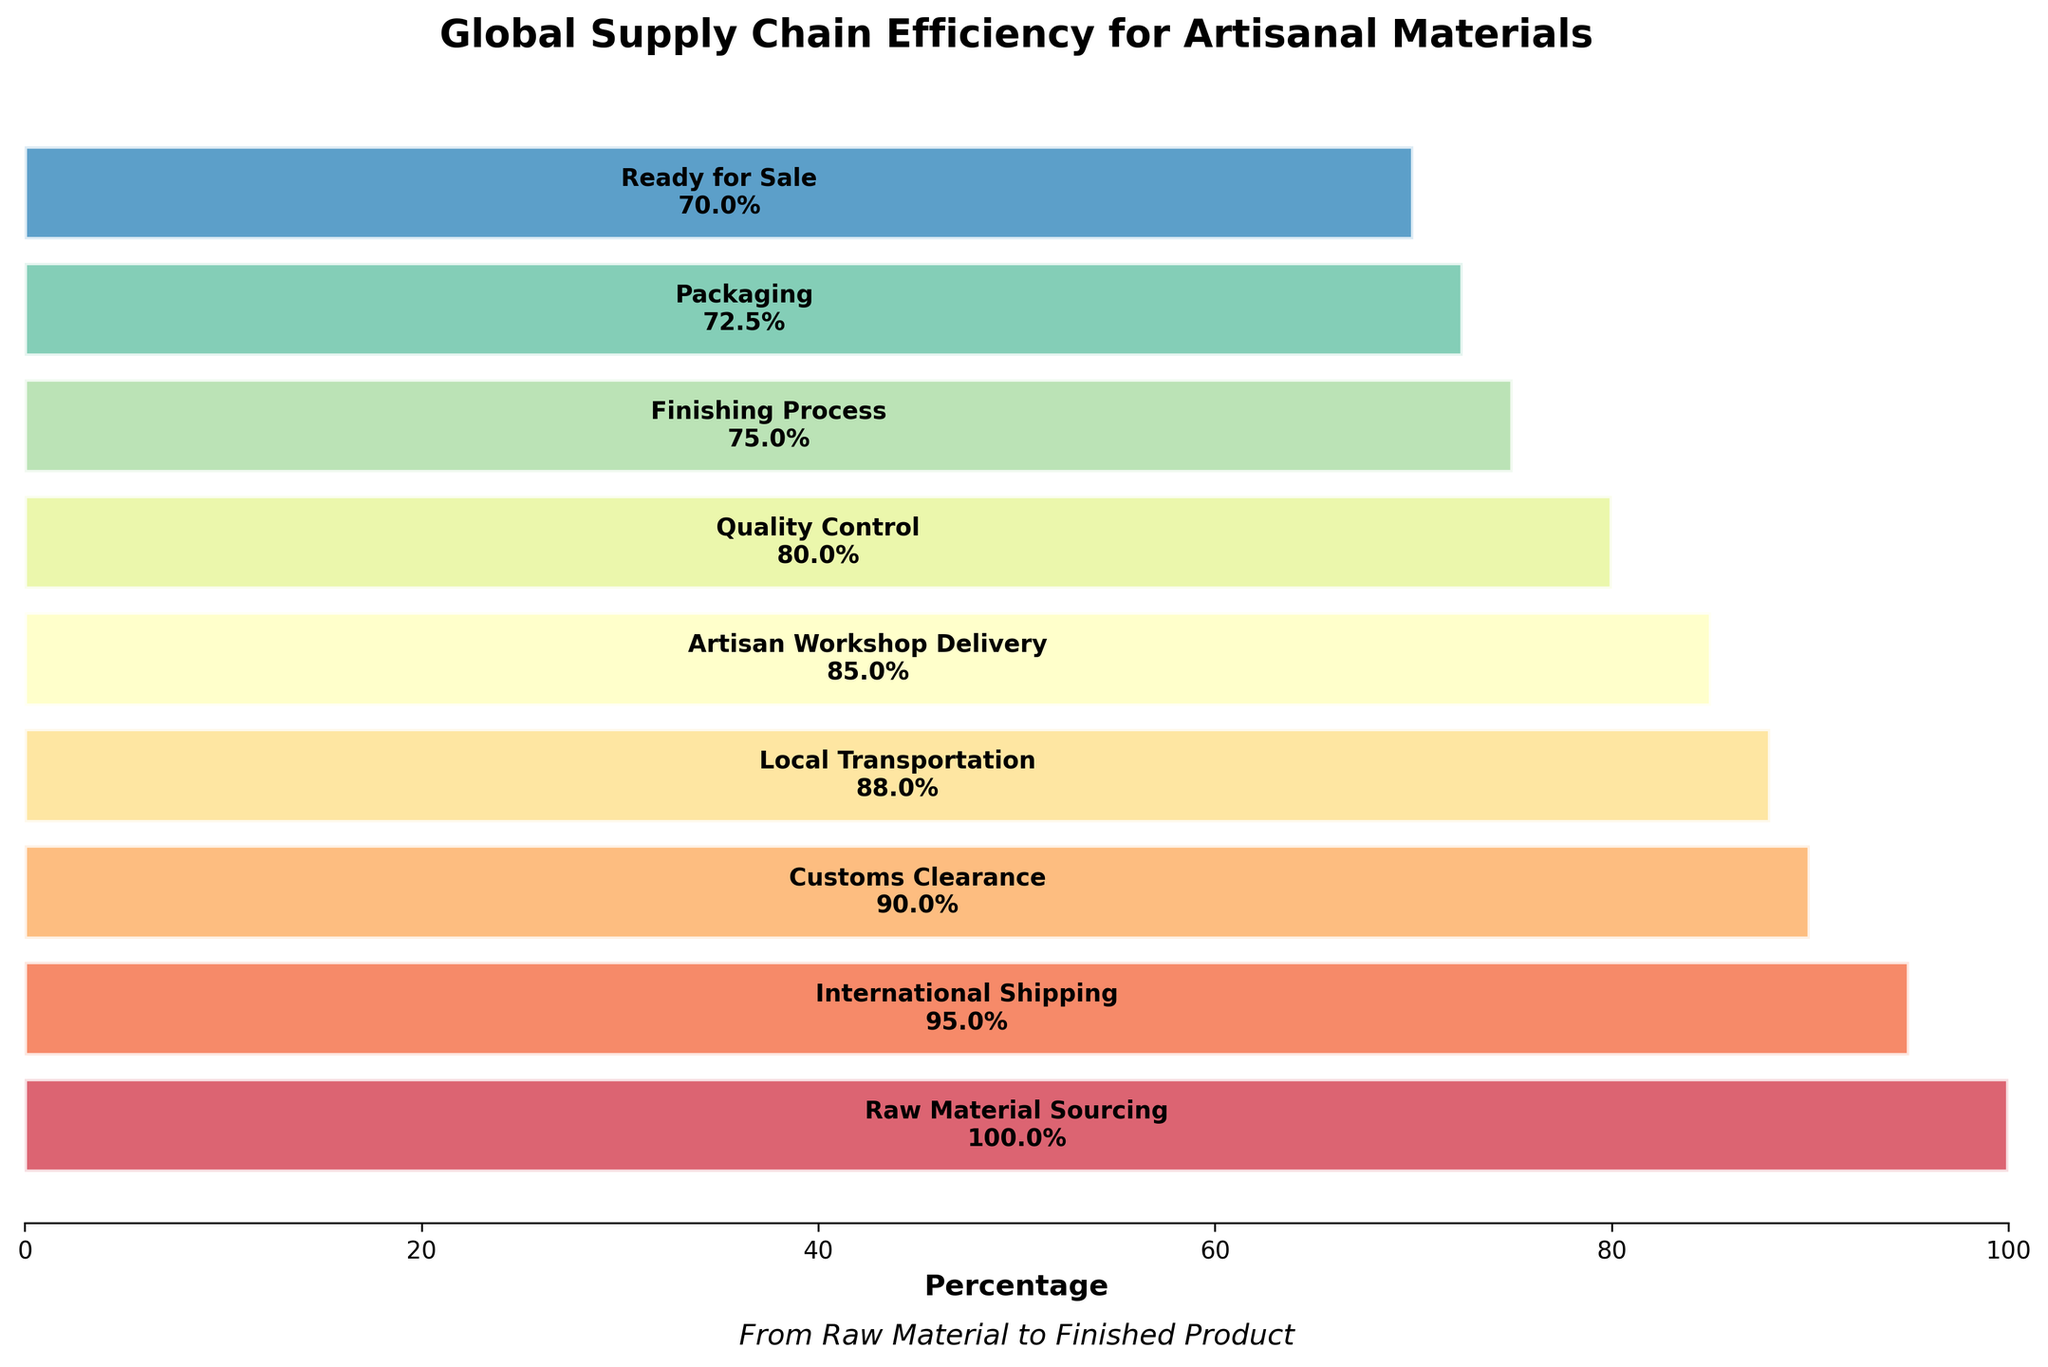What's the title of the figure? The title is displayed at the top of the figure.
Answer: Global Supply Chain Efficiency for Artisanal Materials What percentage of items make it through the Quality Control stage? The percentage at the Quality Control stage is shown directly in the figure.
Answer: 80% How many percentage points are lost between the International Shipping and Customs Clearance stages? Subtract the percentage of items at the Customs Clearance stage from the percentage at the International Shipping stage (95% - 90%).
Answer: 5 percentage points Which stage has the second lowest number of items? Refer to the percentages displayed for each stage and identify the second lowest value.
Answer: Finishing Process What is the difference in percentage between the stages Raw Material Sourcing and Ready for Sale? Subtract the percentage at Ready for Sale from the percentage at Raw Material Sourcing (100% - 70%).
Answer: 30% Which has more items, Local Transportation or Packaging stages? Compare the percentages of Local Transportation (88%) and Packaging (72.5%).
Answer: Local Transportation By how many items does the number decrease from the Artisan Workshop Delivery to the Ready for Sale stage? Subtract the percentage of items at the Ready for Sale stage from the percentage at Artisan Workshop Delivery (85% - 70%), and apply this to the initial quantity of 1000 (15% of 1000).
Answer: 150 items What is the final percentage of items ready for sale? Look at the percentage at the last stage ("Ready for Sale").
Answer: 70% Which stage follows directly after Customs Clearance? Identify the next stage listed after Customs Clearance.
Answer: Local Transportation If 1000 items enter at Raw Material Sourcing, how many items successfully pass through the Finishing Process? Multiply 1000 items by the percentage at the Finishing Process stage (75%).
Answer: 750 items 